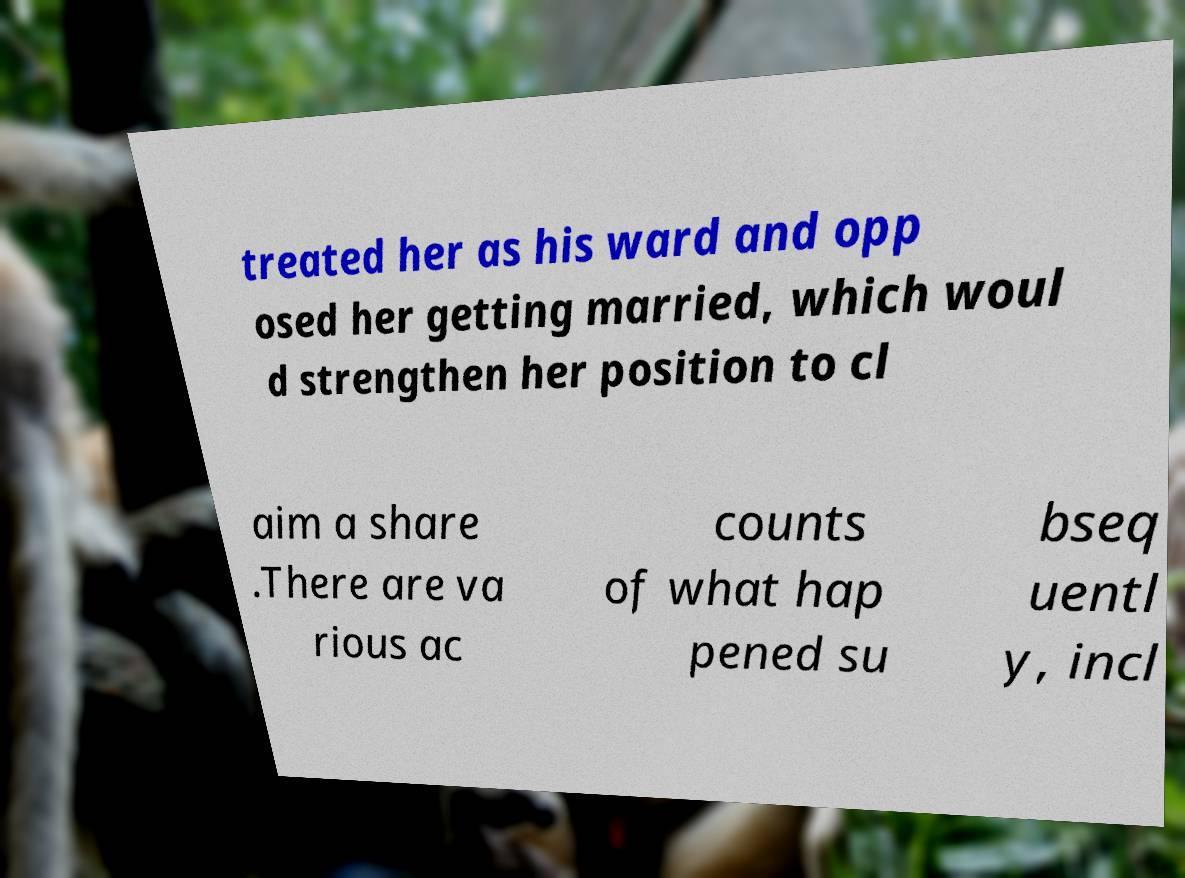Please read and relay the text visible in this image. What does it say? treated her as his ward and opp osed her getting married, which woul d strengthen her position to cl aim a share .There are va rious ac counts of what hap pened su bseq uentl y, incl 